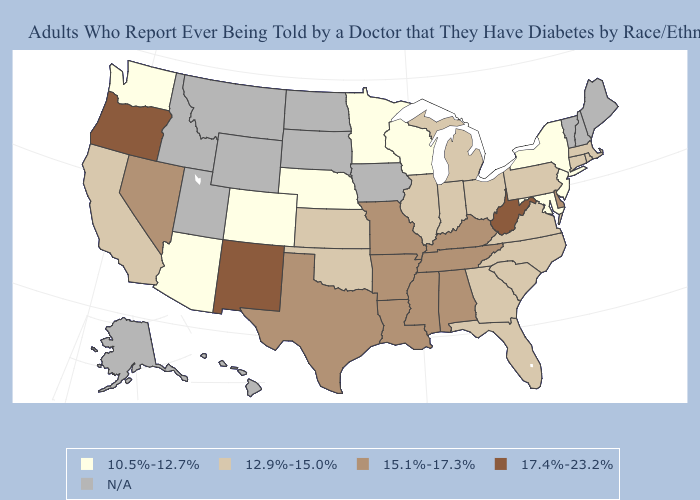Among the states that border Idaho , which have the lowest value?
Quick response, please. Washington. What is the value of Minnesota?
Keep it brief. 10.5%-12.7%. Does the map have missing data?
Give a very brief answer. Yes. What is the lowest value in the USA?
Keep it brief. 10.5%-12.7%. Among the states that border North Carolina , does South Carolina have the lowest value?
Concise answer only. Yes. What is the value of Kentucky?
Give a very brief answer. 15.1%-17.3%. Name the states that have a value in the range 17.4%-23.2%?
Give a very brief answer. New Mexico, Oregon, West Virginia. Does the map have missing data?
Give a very brief answer. Yes. Does the map have missing data?
Keep it brief. Yes. What is the value of Maryland?
Short answer required. 10.5%-12.7%. Does the first symbol in the legend represent the smallest category?
Concise answer only. Yes. Name the states that have a value in the range 17.4%-23.2%?
Be succinct. New Mexico, Oregon, West Virginia. Which states have the lowest value in the Northeast?
Be succinct. New Jersey, New York. What is the value of Tennessee?
Give a very brief answer. 15.1%-17.3%. 